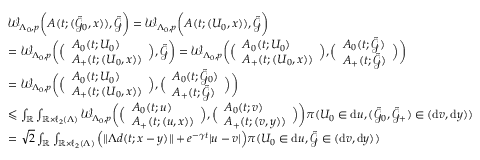Convert formula to latex. <formula><loc_0><loc_0><loc_500><loc_500>\begin{array} { r l } & { \mathcal { W } _ { \Lambda _ { 0 } , p } \left ( A ( t ; ( \tilde { \mathcal { G } } _ { 0 } , x ) ) , \tilde { \mathcal { G } } \right ) = \mathcal { W } _ { \Lambda _ { 0 } , p } \left ( A ( t ; ( U _ { 0 } , x ) ) , \tilde { \mathcal { G } } \right ) } \\ & { = \mathcal { W } _ { \Lambda _ { 0 } , p } \left ( \left ( \begin{array} { l } { A _ { 0 } ( t ; U _ { 0 } ) } \\ { A _ { + } ( t ; ( U _ { 0 } , x ) ) } \end{array} \right ) , \tilde { \mathcal { G } } \right ) = \mathcal { W } _ { \Lambda _ { 0 } , p } \left ( \left ( \begin{array} { l } { A _ { 0 } ( t ; U _ { 0 } ) } \\ { A _ { + } ( t ; ( U _ { 0 } , x ) ) } \end{array} \right ) , \left ( \begin{array} { l } { A _ { 0 } ( t ; \tilde { \mathcal { G } } ) } \\ { A _ { + } ( t ; \tilde { \mathcal { G } } ) } \end{array} \right ) \right ) } \\ & { = \mathcal { W } _ { \Lambda _ { 0 } , p } \left ( \left ( \begin{array} { l } { A _ { 0 } ( t ; U _ { 0 } ) } \\ { A _ { + } ( t ; ( U _ { 0 } , x ) ) } \end{array} \right ) , \left ( \begin{array} { l } { A _ { 0 } ( t ; \tilde { \mathcal { G } } _ { 0 } ) } \\ { A _ { + } ( t ; \tilde { \mathcal { G } } ) } \end{array} \right ) \right ) } \\ & { \leqslant \int _ { \mathbb { R } } \int _ { \mathbb { R } \times \ell _ { 2 } ( \Lambda ) } \mathcal { W } _ { \Lambda _ { 0 } , p } \left ( \left ( \begin{array} { l } { A _ { 0 } ( t ; u ) } \\ { A _ { + } ( t ; ( u , x ) ) } \end{array} \right ) , \left ( \begin{array} { l } { A _ { 0 } ( t ; v ) } \\ { A _ { + } ( t ; ( v , y ) ) } \end{array} \right ) \right ) \pi ( U _ { 0 } \in d u , ( \tilde { \mathcal { G } } _ { 0 } , \tilde { \mathcal { G } } _ { + } ) \in ( d v , d y ) ) } \\ & { = { \sqrt { 2 } } \int _ { \mathbb { R } } \int _ { \mathbb { R } \times \ell _ { 2 } ( \Lambda ) } \left ( \| \Lambda d ( t ; x - y ) \| + e ^ { - \gamma t } | u - v | \right ) \pi ( U _ { 0 } \in d u , \tilde { \mathcal { G } } \in ( d v , d y ) ) } \end{array}</formula> 